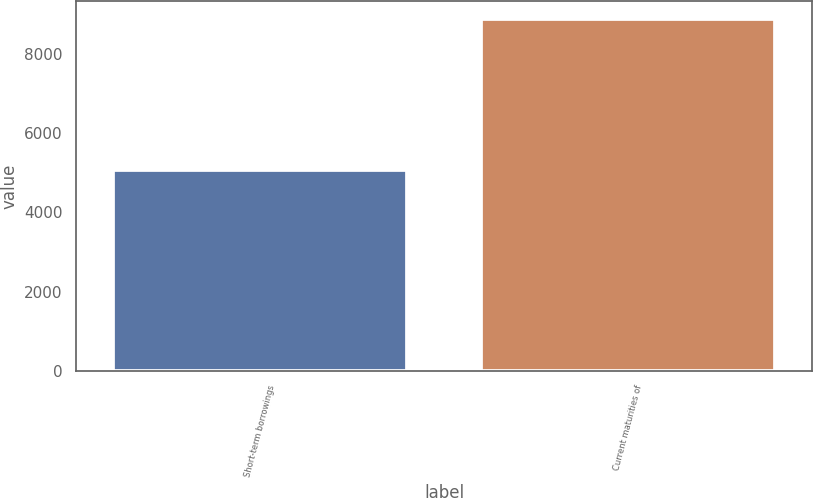<chart> <loc_0><loc_0><loc_500><loc_500><bar_chart><fcel>Short-term borrowings<fcel>Current maturities of<nl><fcel>5056<fcel>8876<nl></chart> 